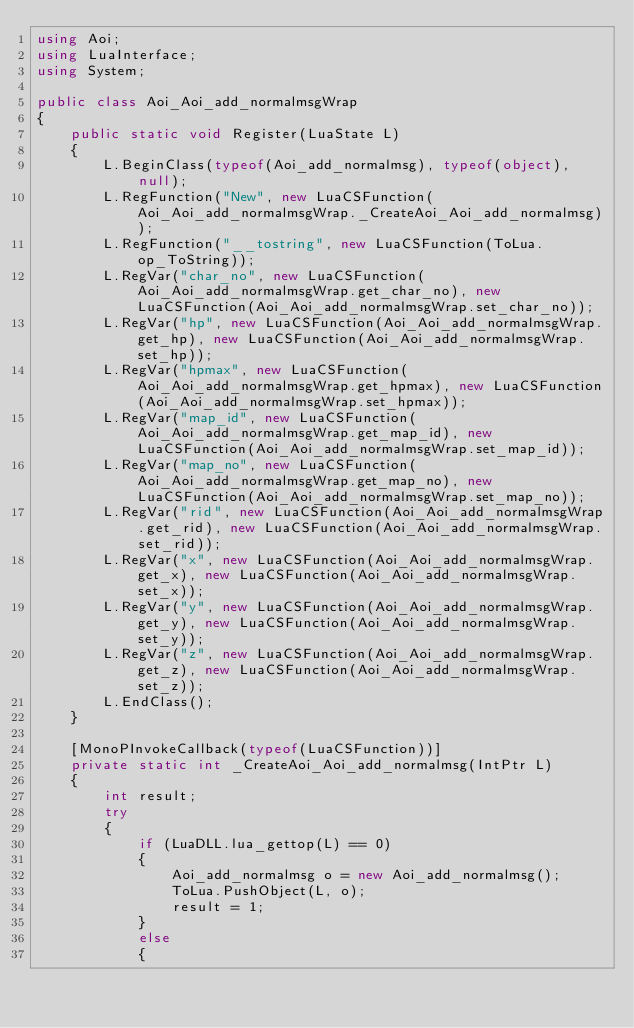Convert code to text. <code><loc_0><loc_0><loc_500><loc_500><_C#_>using Aoi;
using LuaInterface;
using System;

public class Aoi_Aoi_add_normalmsgWrap
{
	public static void Register(LuaState L)
	{
		L.BeginClass(typeof(Aoi_add_normalmsg), typeof(object), null);
		L.RegFunction("New", new LuaCSFunction(Aoi_Aoi_add_normalmsgWrap._CreateAoi_Aoi_add_normalmsg));
		L.RegFunction("__tostring", new LuaCSFunction(ToLua.op_ToString));
		L.RegVar("char_no", new LuaCSFunction(Aoi_Aoi_add_normalmsgWrap.get_char_no), new LuaCSFunction(Aoi_Aoi_add_normalmsgWrap.set_char_no));
		L.RegVar("hp", new LuaCSFunction(Aoi_Aoi_add_normalmsgWrap.get_hp), new LuaCSFunction(Aoi_Aoi_add_normalmsgWrap.set_hp));
		L.RegVar("hpmax", new LuaCSFunction(Aoi_Aoi_add_normalmsgWrap.get_hpmax), new LuaCSFunction(Aoi_Aoi_add_normalmsgWrap.set_hpmax));
		L.RegVar("map_id", new LuaCSFunction(Aoi_Aoi_add_normalmsgWrap.get_map_id), new LuaCSFunction(Aoi_Aoi_add_normalmsgWrap.set_map_id));
		L.RegVar("map_no", new LuaCSFunction(Aoi_Aoi_add_normalmsgWrap.get_map_no), new LuaCSFunction(Aoi_Aoi_add_normalmsgWrap.set_map_no));
		L.RegVar("rid", new LuaCSFunction(Aoi_Aoi_add_normalmsgWrap.get_rid), new LuaCSFunction(Aoi_Aoi_add_normalmsgWrap.set_rid));
		L.RegVar("x", new LuaCSFunction(Aoi_Aoi_add_normalmsgWrap.get_x), new LuaCSFunction(Aoi_Aoi_add_normalmsgWrap.set_x));
		L.RegVar("y", new LuaCSFunction(Aoi_Aoi_add_normalmsgWrap.get_y), new LuaCSFunction(Aoi_Aoi_add_normalmsgWrap.set_y));
		L.RegVar("z", new LuaCSFunction(Aoi_Aoi_add_normalmsgWrap.get_z), new LuaCSFunction(Aoi_Aoi_add_normalmsgWrap.set_z));
		L.EndClass();
	}

	[MonoPInvokeCallback(typeof(LuaCSFunction))]
	private static int _CreateAoi_Aoi_add_normalmsg(IntPtr L)
	{
		int result;
		try
		{
			if (LuaDLL.lua_gettop(L) == 0)
			{
				Aoi_add_normalmsg o = new Aoi_add_normalmsg();
				ToLua.PushObject(L, o);
				result = 1;
			}
			else
			{</code> 